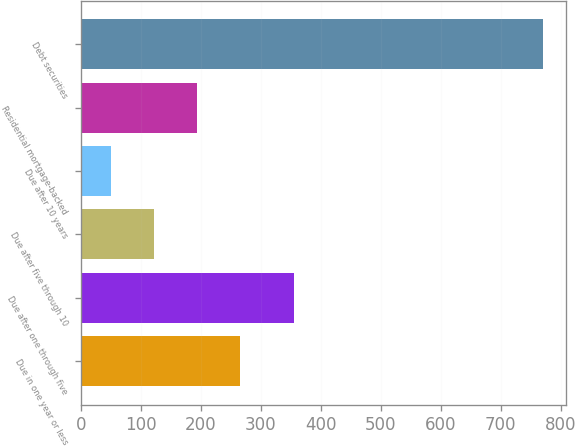<chart> <loc_0><loc_0><loc_500><loc_500><bar_chart><fcel>Due in one year or less<fcel>Due after one through five<fcel>Due after five through 10<fcel>Due after 10 years<fcel>Residential mortgage-backed<fcel>Debt securities<nl><fcel>266<fcel>355<fcel>122<fcel>50<fcel>194<fcel>770<nl></chart> 